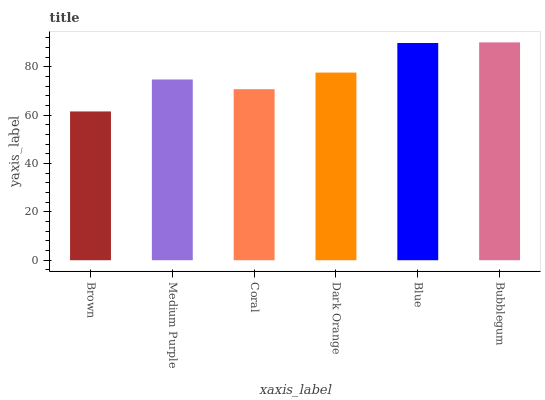Is Brown the minimum?
Answer yes or no. Yes. Is Bubblegum the maximum?
Answer yes or no. Yes. Is Medium Purple the minimum?
Answer yes or no. No. Is Medium Purple the maximum?
Answer yes or no. No. Is Medium Purple greater than Brown?
Answer yes or no. Yes. Is Brown less than Medium Purple?
Answer yes or no. Yes. Is Brown greater than Medium Purple?
Answer yes or no. No. Is Medium Purple less than Brown?
Answer yes or no. No. Is Dark Orange the high median?
Answer yes or no. Yes. Is Medium Purple the low median?
Answer yes or no. Yes. Is Bubblegum the high median?
Answer yes or no. No. Is Brown the low median?
Answer yes or no. No. 